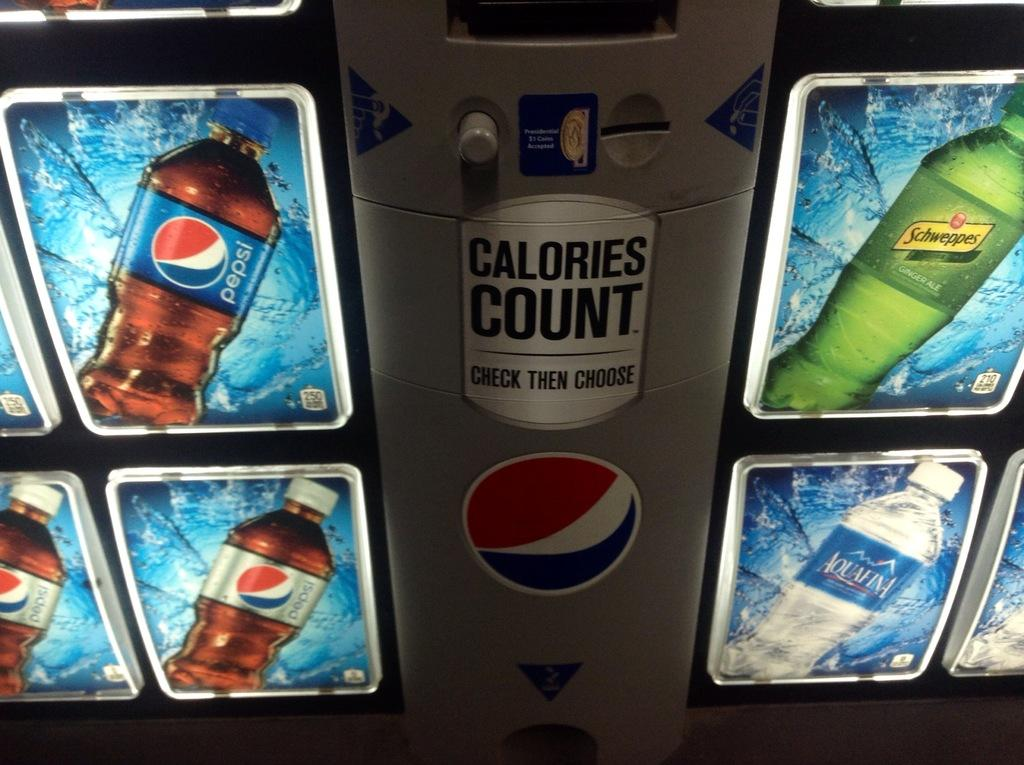Provide a one-sentence caption for the provided image. A soda machine with Pepsi, diet Pepsi and Aquafina. 